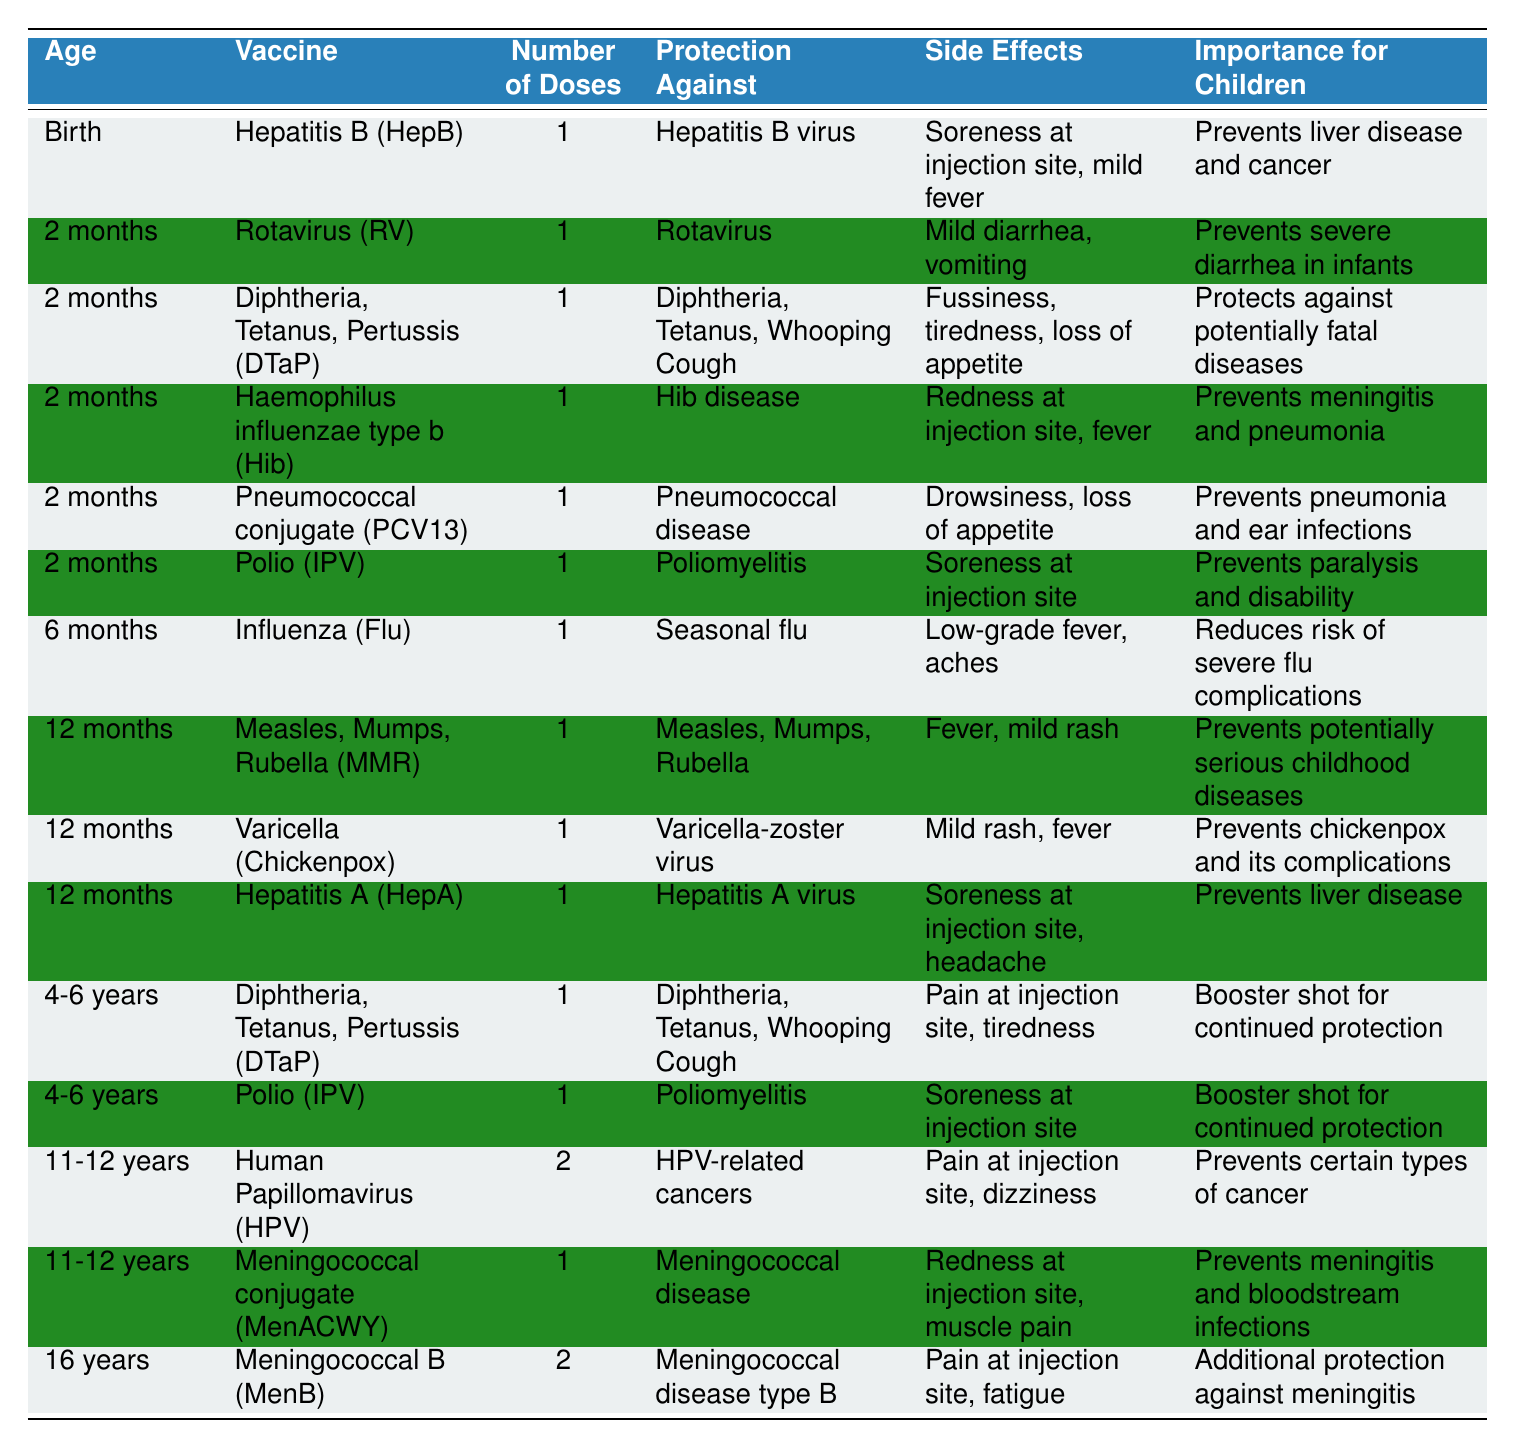What vaccine is given at birth? According to the table, the vaccine given at birth is Hepatitis B (HepB).
Answer: Hepatitis B (HepB) How many doses of the Measles, Mumps, Rubella (MMR) vaccine are required? The table indicates that the Measles, Mumps, Rubella (MMR) vaccine requires 1 dose at 12 months of age.
Answer: 1 dose What are the side effects of the Polio vaccine at 2 months? The table specifies that the side effects of the Polio vaccine (IPV) at 2 months include soreness at the injection site.
Answer: Soreness at injection site Which vaccine is important for preventing pneumonia in children? The table shows that the Pneumococcal conjugate (PCV13) vaccine at 2 months is crucial for preventing pneumonia and ear infections.
Answer: Pneumococcal conjugate (PCV13) How many vaccines listed are administered at 2 months? Counting from the table, there are 5 vaccines administered at 2 months: Rotavirus (RV), DTaP, Hib, PCV13, and Polio (IPV).
Answer: 5 vaccines Is the DTaP vaccine given again at 4-6 years? Yes, the table indicates that a booster shot of the DTaP vaccine is administered again at 4-6 years for continued protection.
Answer: Yes Which vaccine has the highest number of doses required at the 11-12 years stage? The Human Papillomavirus (HPV) vaccine requires 2 doses at the 11-12 years stage, more than any other vaccine at this age group.
Answer: Human Papillomavirus (HPV) What vaccines require pain at the injection site as a side effect? The table lists the following vaccines with pain at the injection site as a side effect: HepB, IPV (2 months), DTaP (4-6 years), HPV, MenB.
Answer: HepB, IPV, DTaP, HPV, MenB How many vaccines target meningococcal disease? According to the table, there are 2 vaccines that target meningococcal disease: Meningococcal conjugate (MenACWY) and Meningococcal B (MenB).
Answer: 2 vaccines At what age do children receive the Varicella (Chickenpox) vaccine? The table states that the Varicella (Chickenpox) vaccine is administered at 12 months of age.
Answer: 12 months Which vaccine prevents liver disease and cancer? The Hepatitis B (HepB) vaccine prevents liver disease and cancer, as noted in the table.
Answer: Hepatitis B (HepB) What is the total number of doses required for the Meningococcal B vaccine? The Meningococcal B (MenB) vaccine requires 2 doses at the age of 16 years, as seen in the table.
Answer: 2 doses Are mild diarrhea or vomiting side effects of any vaccines listed? Yes, mild diarrhea and vomiting are side effects of the Rotavirus (RV) vaccine, as indicated in the table.
Answer: Yes What is the role of the Influenza vaccine in children's health? The Influenza (Flu) vaccine reduces the risk of severe flu complications, as stated in the importance section of the table.
Answer: Reduces risk of severe flu complications Which of the vaccines listed are given in the early infancy stage (0-6 months)? The vaccines given in the early infancy stage are HepB (at birth), RV, DTaP, Hib, PCV13, and Influenza (at 6 months), totaling 6 vaccines.
Answer: 6 vaccines What side effects are associated with the Meningococcal conjugate (MenACWY) vaccine? The side effects of the Meningococcal conjugate (MenACWY) vaccine include redness at the injection site and muscle pain, as listed in the table.
Answer: Redness at injection site, muscle pain 